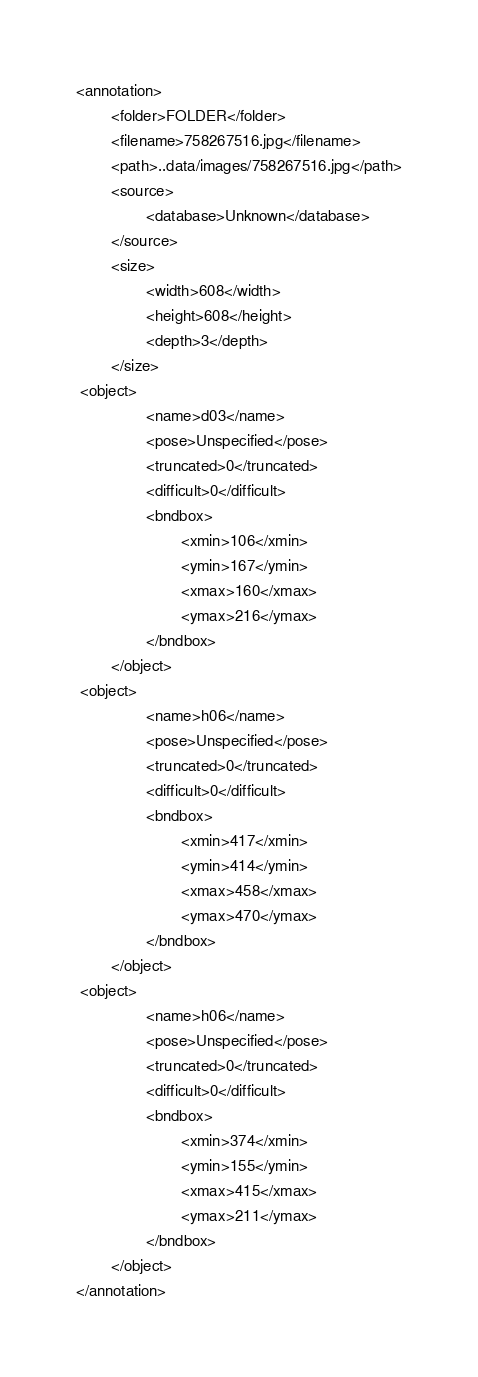Convert code to text. <code><loc_0><loc_0><loc_500><loc_500><_XML_><annotation>
        <folder>FOLDER</folder>
        <filename>758267516.jpg</filename>
        <path>..data/images/758267516.jpg</path>
        <source>
                <database>Unknown</database>
        </source>
        <size>
                <width>608</width>
                <height>608</height>
                <depth>3</depth>
        </size>
 <object>
                <name>d03</name>
                <pose>Unspecified</pose>
                <truncated>0</truncated>
                <difficult>0</difficult>
                <bndbox>
                        <xmin>106</xmin>
                        <ymin>167</ymin>
                        <xmax>160</xmax>
                        <ymax>216</ymax>
                </bndbox>
        </object>
 <object>
                <name>h06</name>
                <pose>Unspecified</pose>
                <truncated>0</truncated>
                <difficult>0</difficult>
                <bndbox>
                        <xmin>417</xmin>
                        <ymin>414</ymin>
                        <xmax>458</xmax>
                        <ymax>470</ymax>
                </bndbox>
        </object>
 <object>
                <name>h06</name>
                <pose>Unspecified</pose>
                <truncated>0</truncated>
                <difficult>0</difficult>
                <bndbox>
                        <xmin>374</xmin>
                        <ymin>155</ymin>
                        <xmax>415</xmax>
                        <ymax>211</ymax>
                </bndbox>
        </object>
</annotation>
</code> 